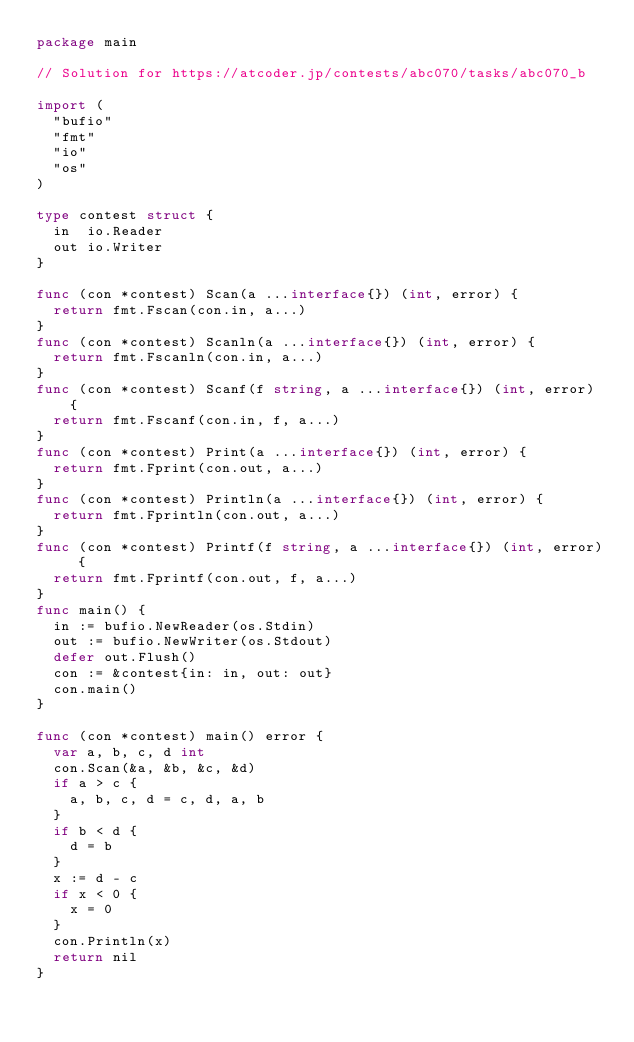<code> <loc_0><loc_0><loc_500><loc_500><_Go_>package main

// Solution for https://atcoder.jp/contests/abc070/tasks/abc070_b

import (
	"bufio"
	"fmt"
	"io"
	"os"
)

type contest struct {
	in  io.Reader
	out io.Writer
}

func (con *contest) Scan(a ...interface{}) (int, error) {
	return fmt.Fscan(con.in, a...)
}
func (con *contest) Scanln(a ...interface{}) (int, error) {
	return fmt.Fscanln(con.in, a...)
}
func (con *contest) Scanf(f string, a ...interface{}) (int, error) {
	return fmt.Fscanf(con.in, f, a...)
}
func (con *contest) Print(a ...interface{}) (int, error) {
	return fmt.Fprint(con.out, a...)
}
func (con *contest) Println(a ...interface{}) (int, error) {
	return fmt.Fprintln(con.out, a...)
}
func (con *contest) Printf(f string, a ...interface{}) (int, error) {
	return fmt.Fprintf(con.out, f, a...)
}
func main() {
	in := bufio.NewReader(os.Stdin)
	out := bufio.NewWriter(os.Stdout)
	defer out.Flush()
	con := &contest{in: in, out: out}
	con.main()
}

func (con *contest) main() error {
	var a, b, c, d int
	con.Scan(&a, &b, &c, &d)
	if a > c {
		a, b, c, d = c, d, a, b
	}
	if b < d {
		d = b
	}
	x := d - c
	if x < 0 {
		x = 0
	}
	con.Println(x)
	return nil
}
</code> 